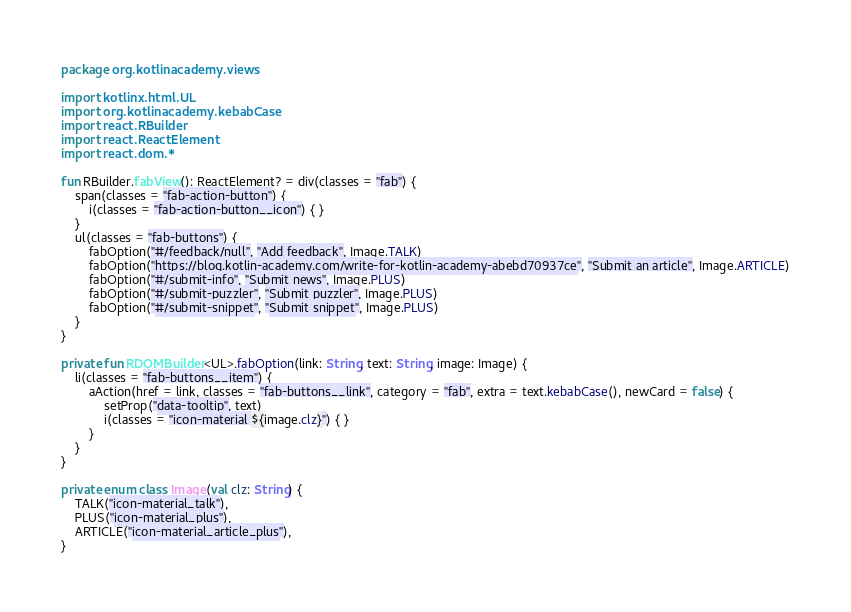<code> <loc_0><loc_0><loc_500><loc_500><_Kotlin_>package org.kotlinacademy.views

import kotlinx.html.UL
import org.kotlinacademy.kebabCase
import react.RBuilder
import react.ReactElement
import react.dom.*

fun RBuilder.fabView(): ReactElement? = div(classes = "fab") {
    span(classes = "fab-action-button") {
        i(classes = "fab-action-button__icon") { }
    }
    ul(classes = "fab-buttons") {
        fabOption("#/feedback/null", "Add feedback", Image.TALK)
        fabOption("https://blog.kotlin-academy.com/write-for-kotlin-academy-abebd70937ce", "Submit an article", Image.ARTICLE)
        fabOption("#/submit-info", "Submit news", Image.PLUS)
        fabOption("#/submit-puzzler", "Submit puzzler", Image.PLUS)
        fabOption("#/submit-snippet", "Submit snippet", Image.PLUS)
    }
}

private fun RDOMBuilder<UL>.fabOption(link: String, text: String, image: Image) {
    li(classes = "fab-buttons__item") {
        aAction(href = link, classes = "fab-buttons__link", category = "fab", extra = text.kebabCase(), newCard = false) {
            setProp("data-tooltip", text)
            i(classes = "icon-material ${image.clz}") { }
        }
    }
}

private enum class Image(val clz: String) {
    TALK("icon-material_talk"),
    PLUS("icon-material_plus"),
    ARTICLE("icon-material_article_plus"),
}</code> 